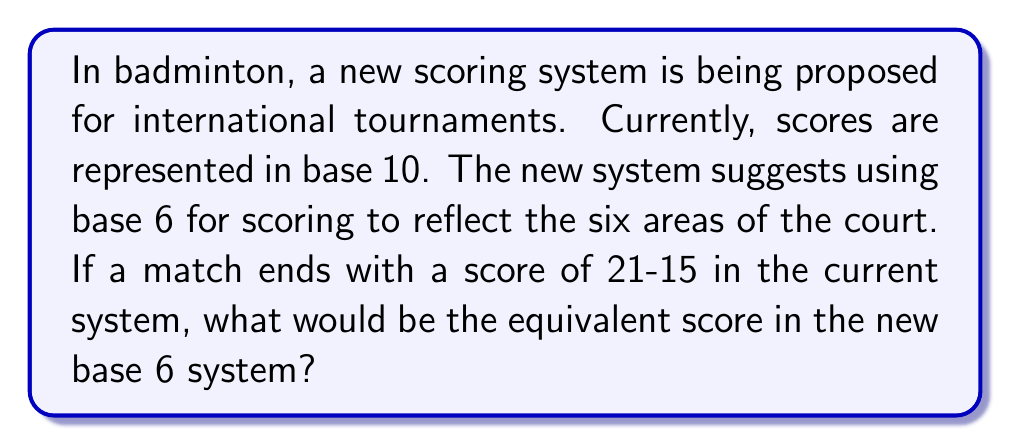Teach me how to tackle this problem. To convert the scores from base 10 to base 6, we need to perform the following steps for each score:

1. For 21 (base 10):
   $21 \div 6 = 3$ remainder $3$
   $3 \div 6 = 0$ remainder $3$
   
   So, 21 in base 6 is $33_6$

2. For 15 (base 10):
   $15 \div 6 = 2$ remainder $3$
   $2 \div 6 = 0$ remainder $2$
   
   So, 15 in base 6 is $23_6$

The conversion process can be represented mathematically as:

For 21:
$$21 = 3 \times 6^1 + 3 \times 6^0 = 18 + 3 = 21_{10} = 33_6$$

For 15:
$$15 = 2 \times 6^1 + 3 \times 6^0 = 12 + 3 = 15_{10} = 23_6$$

Therefore, the score 21-15 in base 10 is equivalent to $33_6$-$23_6$ in base 6.
Answer: $33_6$-$23_6$ 